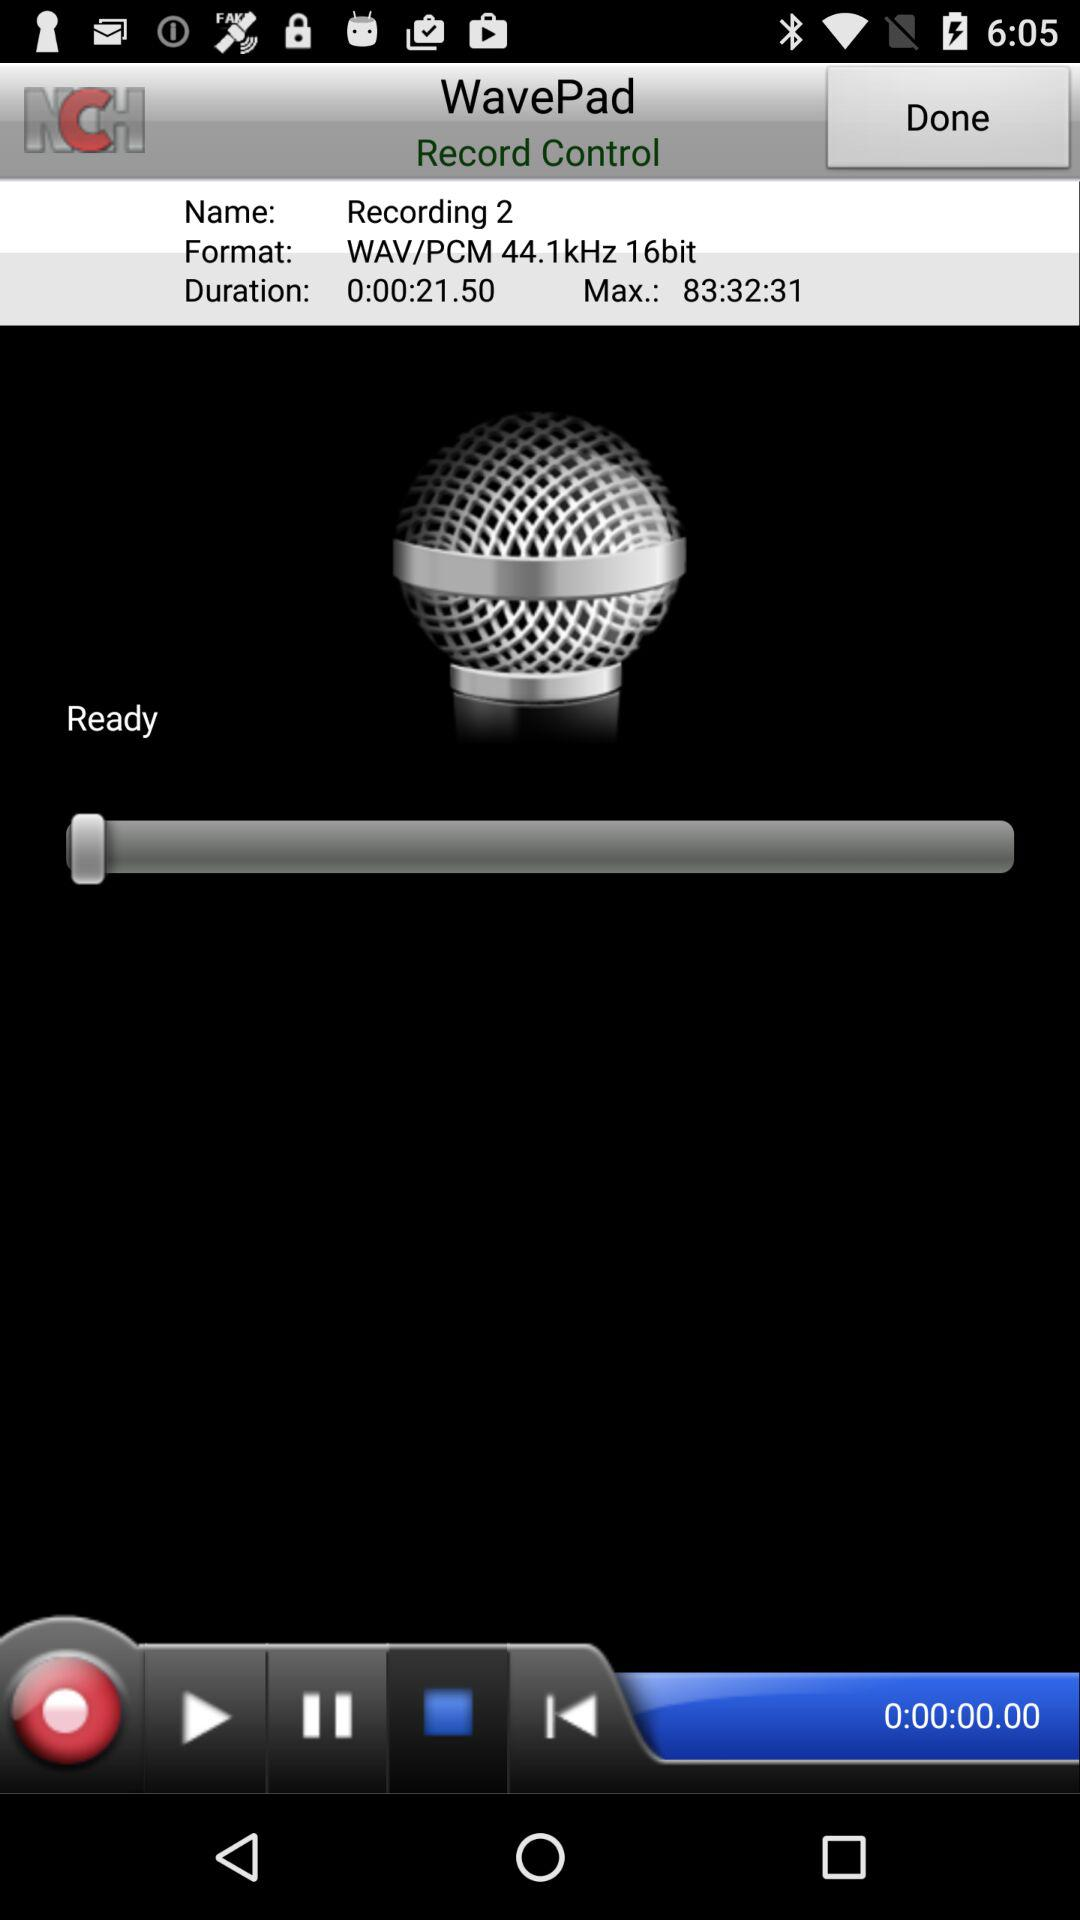What is the format? The format is "WAV/PCM 44.1kHz 16bit". 